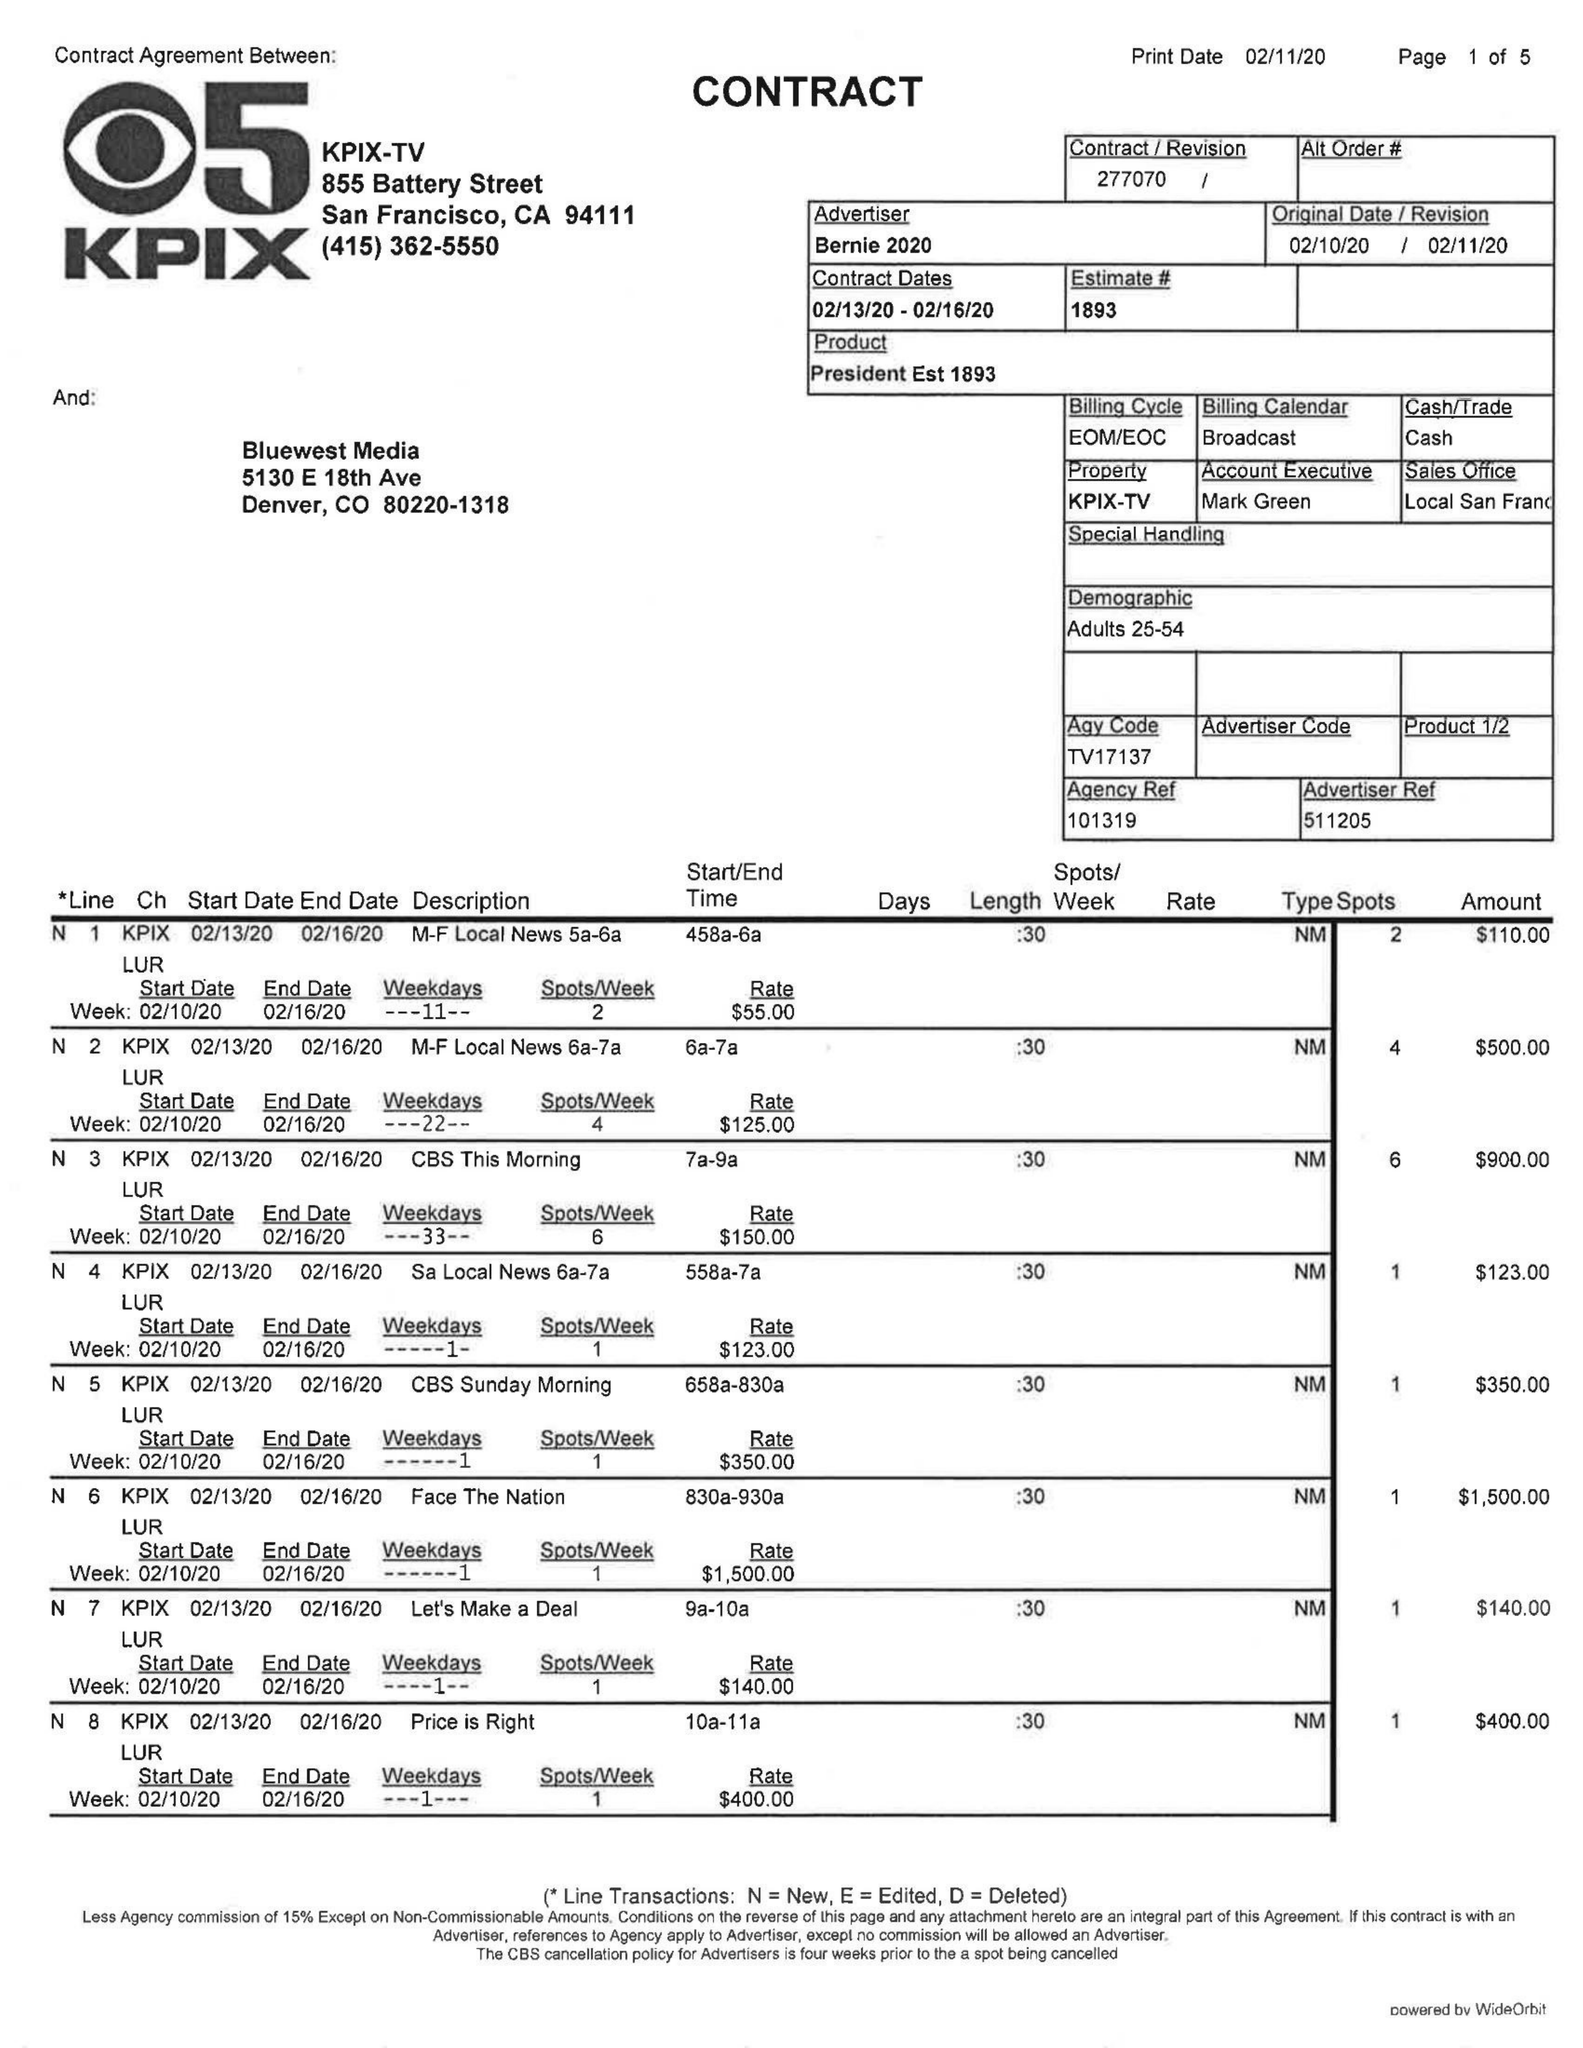What is the value for the contract_num?
Answer the question using a single word or phrase. 277070 